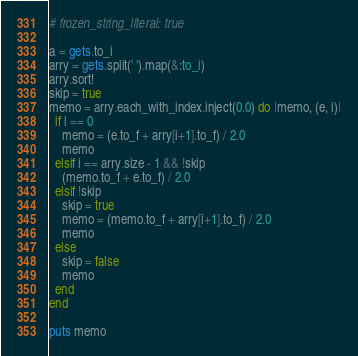Convert code to text. <code><loc_0><loc_0><loc_500><loc_500><_Ruby_># frozen_string_literal: true

a = gets.to_i
arry = gets.split(' ').map(&:to_i)
arry.sort!
skip = true
memo = arry.each_with_index.inject(0.0) do |memo, (e, i)|
  if i == 0
    memo = (e.to_f + arry[i+1].to_f) / 2.0
    memo
  elsif i == arry.size - 1 && !skip
    (memo.to_f + e.to_f) / 2.0
  elsif !skip
    skip = true
    memo = (memo.to_f + arry[i+1].to_f) / 2.0
    memo
  else
    skip = false
    memo
  end
end

puts memo
</code> 